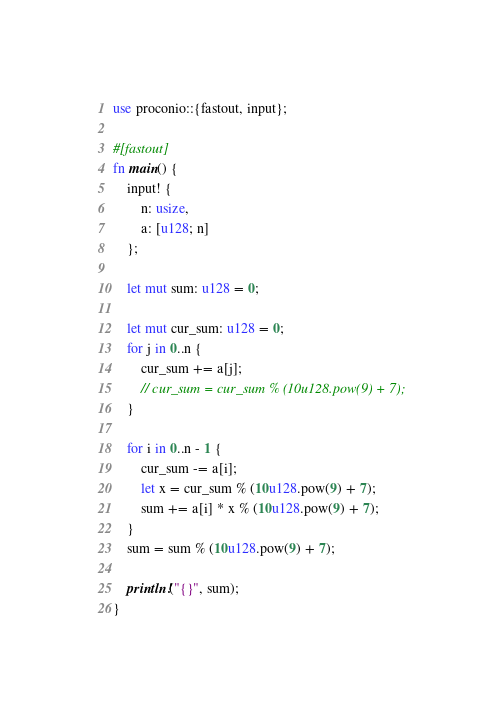Convert code to text. <code><loc_0><loc_0><loc_500><loc_500><_Rust_>use proconio::{fastout, input};

#[fastout]
fn main() {
    input! {
        n: usize,
        a: [u128; n]
    };

    let mut sum: u128 = 0;

    let mut cur_sum: u128 = 0;
    for j in 0..n {
        cur_sum += a[j];
        // cur_sum = cur_sum % (10u128.pow(9) + 7);
    }

    for i in 0..n - 1 {
        cur_sum -= a[i];
        let x = cur_sum % (10u128.pow(9) + 7);
        sum += a[i] * x % (10u128.pow(9) + 7);
    }
    sum = sum % (10u128.pow(9) + 7);

    println!("{}", sum);
}
</code> 